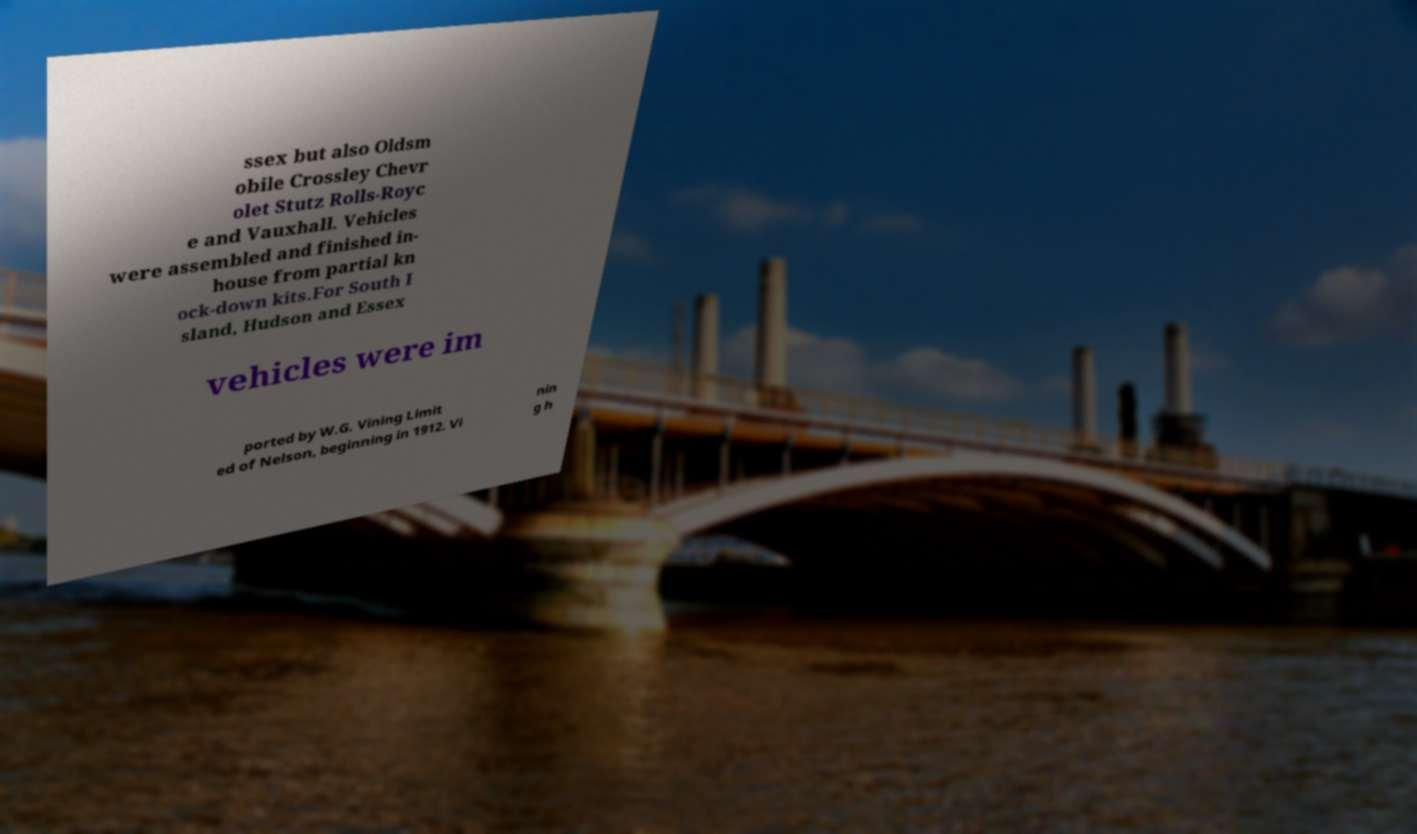For documentation purposes, I need the text within this image transcribed. Could you provide that? ssex but also Oldsm obile Crossley Chevr olet Stutz Rolls-Royc e and Vauxhall. Vehicles were assembled and finished in- house from partial kn ock-down kits.For South I sland, Hudson and Essex vehicles were im ported by W.G. Vining Limit ed of Nelson, beginning in 1912. Vi nin g h 